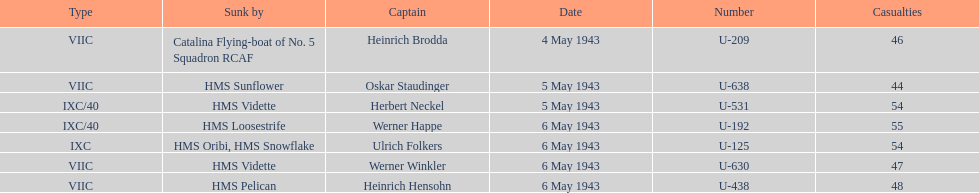Which ship sunk the most u-boats HMS Vidette. 